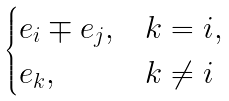Convert formula to latex. <formula><loc_0><loc_0><loc_500><loc_500>\begin{cases} e _ { i } \mp e _ { j } , & k = i , \\ e _ { k } , & k \neq i \end{cases}</formula> 